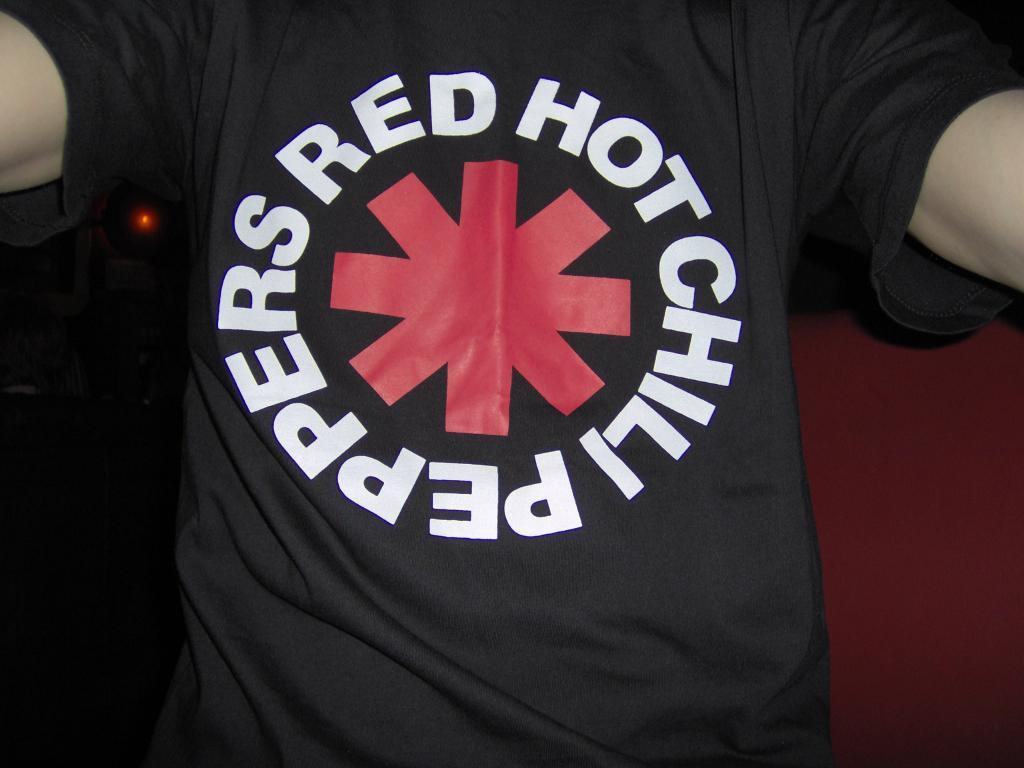<image>
Offer a succinct explanation of the picture presented. a Red Hot Chili Peppers shirt on a person 